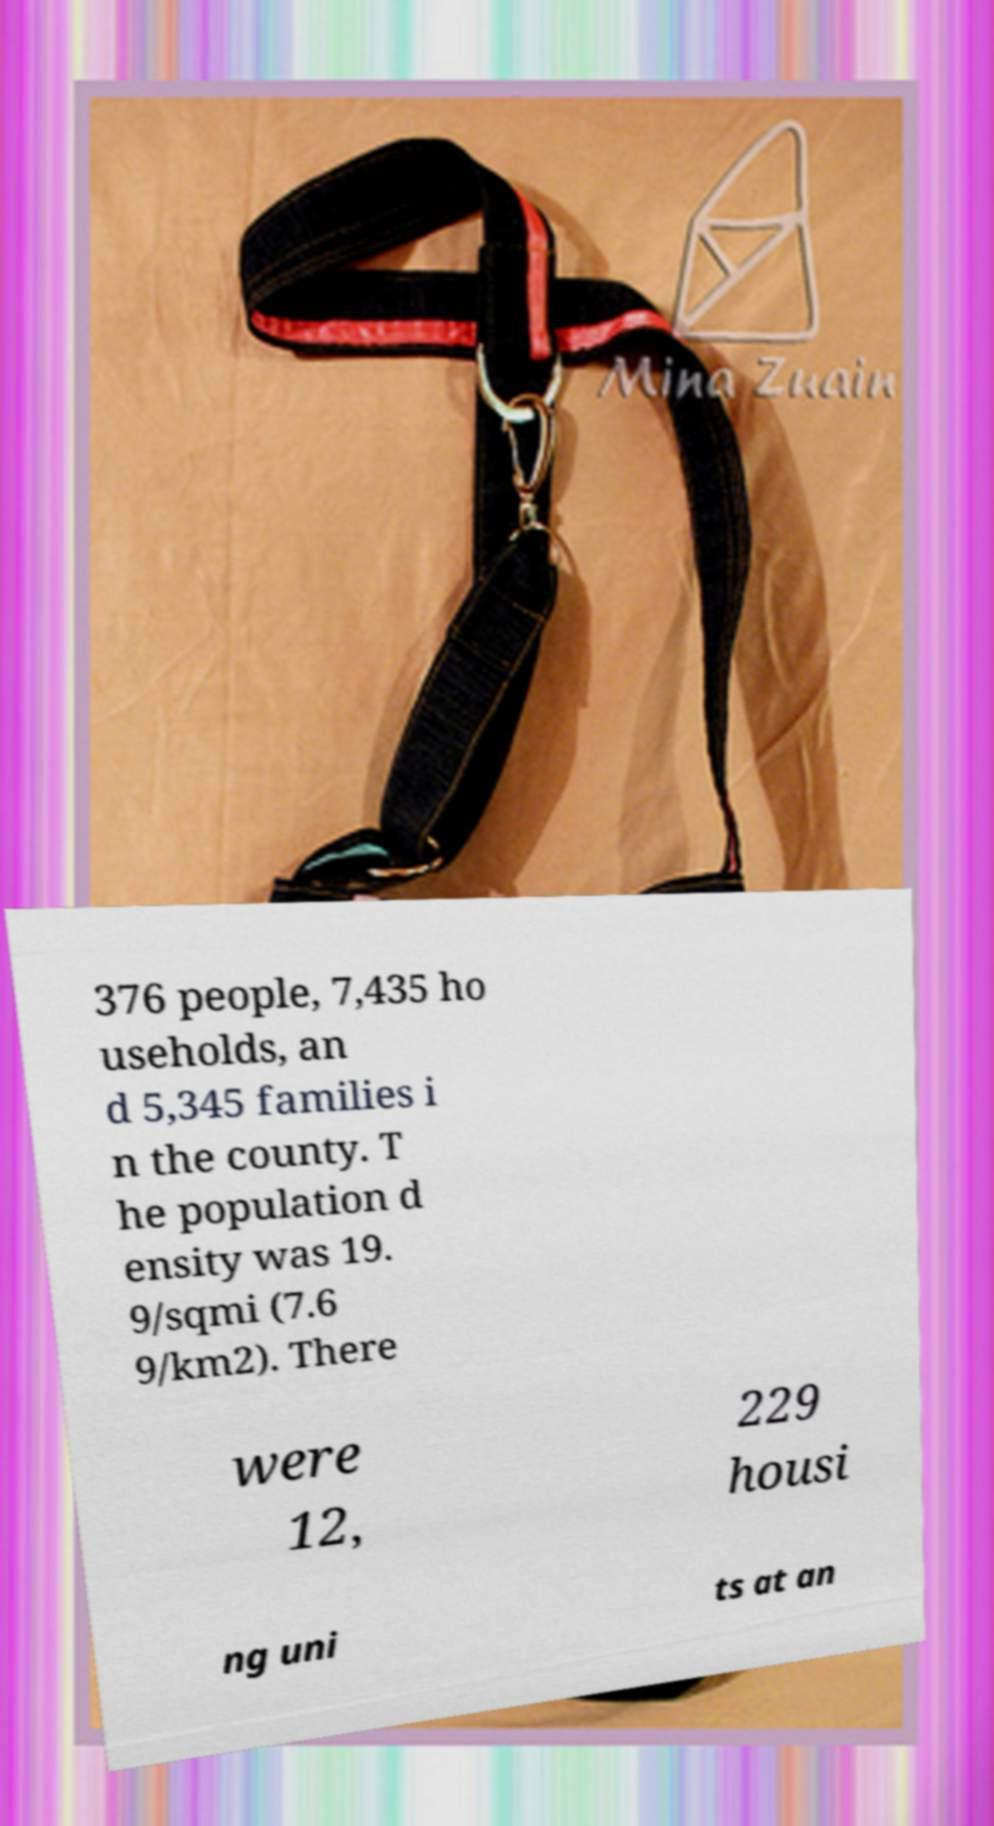I need the written content from this picture converted into text. Can you do that? 376 people, 7,435 ho useholds, an d 5,345 families i n the county. T he population d ensity was 19. 9/sqmi (7.6 9/km2). There were 12, 229 housi ng uni ts at an 